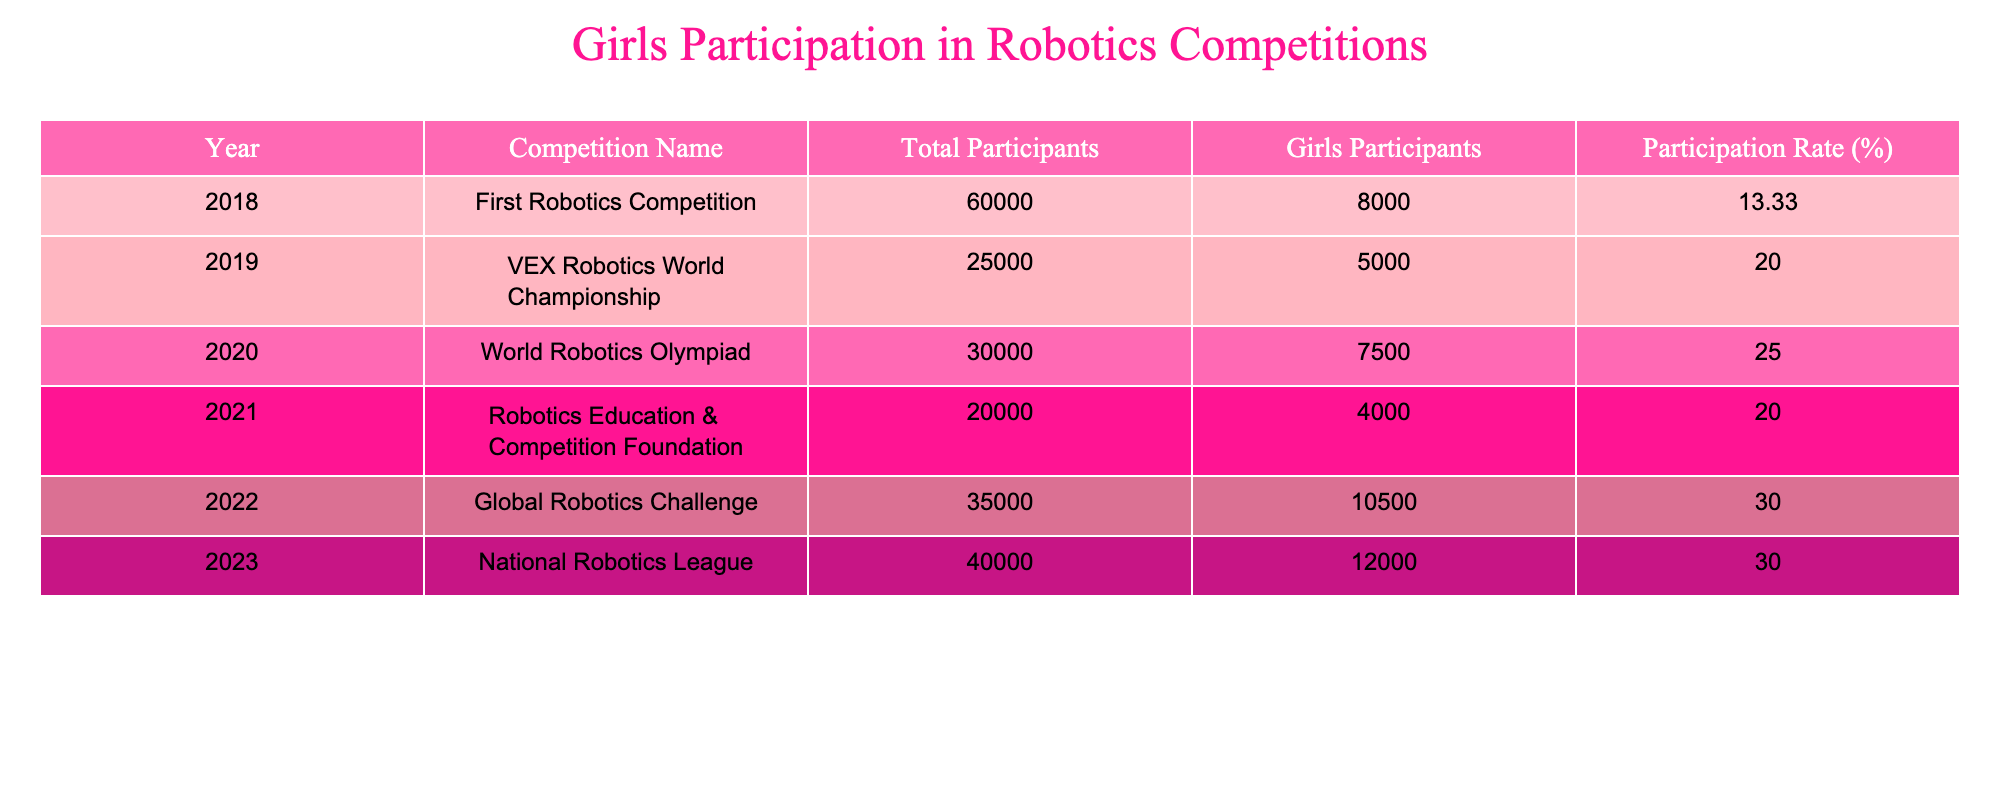What year had the highest number of girls participating in robotics competitions? Looking at the table, the year 2023 has the highest number of girls participating, with 12,000.
Answer: 2023 What is the participation rate of girls in the 2022 Global Robotics Challenge? The participation rate for girls in the 2022 Global Robotics Challenge is 30%, as listed in the table.
Answer: 30% Which competition had the lowest participation rate for girls? In 2018, the First Robotics Competition had the lowest participation rate for girls at 13.33%.
Answer: 13.33% What was the total number of participants in the VEX Robotics World Championship in 2019? The total number of participants in the VEX Robotics World Championship in 2019 is 25,000, as shown in the table.
Answer: 25000 How many more girls participated in 2023 compared to 2018? In 2023, there were 12,000 girls and in 2018 there were 8,000. The difference is 12,000 - 8,000 = 4,000 more girls.
Answer: 4000 What is the average participation rate of girls across all competitions from 2018 to 2023? Adding the participation rates: 13.33 + 20.00 + 25.00 + 20.00 + 30.00 + 30.00 = 138.33. There are 6 years total, so the average is 138.33 / 6 ≈ 23.06%.
Answer: 23.06% Did the participation rate of girls increase from 2021 to 2022? Yes, the participation rate increased from 20% in 2021 to 30% in 2022, which indicates an increase.
Answer: Yes Which year saw a 25% participation rate among girls, and how does it compare to the following year? The year 2020 saw a 25% participation rate, while in 2021, the rate dropped to 20%. This shows a decrease of 5%.
Answer: 2020, decrease What is the difference in total participants between the 2021 Robotics Education & Competition Foundation and the 2023 National Robotics League? The total participants in 2021 were 20,000, and in 2023, it was 40,000. The difference is 40,000 - 20,000 = 20,000 more participants in 2023.
Answer: 20000 In how many years did the participation rate of girls exceed 25%? The participation rates exceeded 25% in 2020, 2022, and 2023, which is a total of 3 years.
Answer: 3 